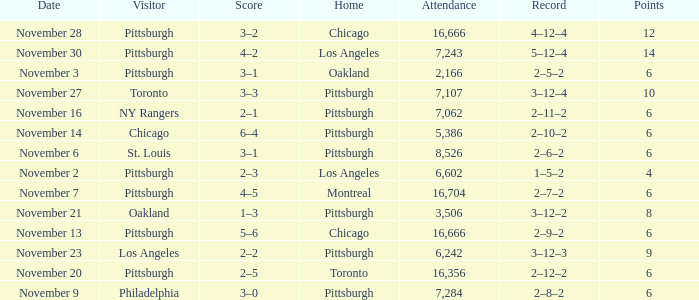What is the sum of the points of the game with philadelphia as the visitor and an attendance greater than 7,284? None. 